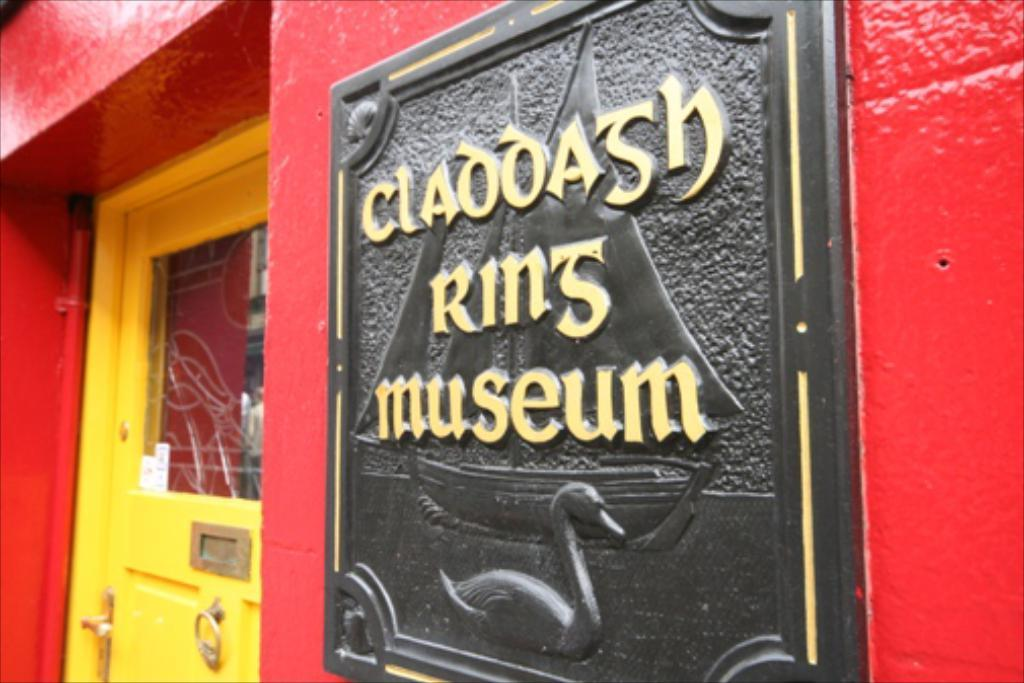What color is the wall that is visible in the image? There is a red-colored wall in the image. What is written or depicted on the wall? There is text on the wall in the image. What type of artwork is present on the wall? There are sculptures on the wall in the image. Where is the door located in the image? The door is on the left side of the image. What type of lunch is being served in the image? There is no lunch present in the image; it features a red-colored wall with text and sculptures, as well as a door on the left side. 